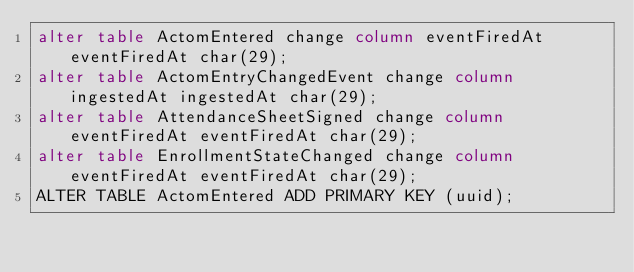Convert code to text. <code><loc_0><loc_0><loc_500><loc_500><_SQL_>alter table ActomEntered change column eventFiredAt eventFiredAt char(29);
alter table ActomEntryChangedEvent change column ingestedAt ingestedAt char(29);
alter table AttendanceSheetSigned change column eventFiredAt eventFiredAt char(29);
alter table EnrollmentStateChanged change column eventFiredAt eventFiredAt char(29);
ALTER TABLE ActomEntered ADD PRIMARY KEY (uuid);
</code> 